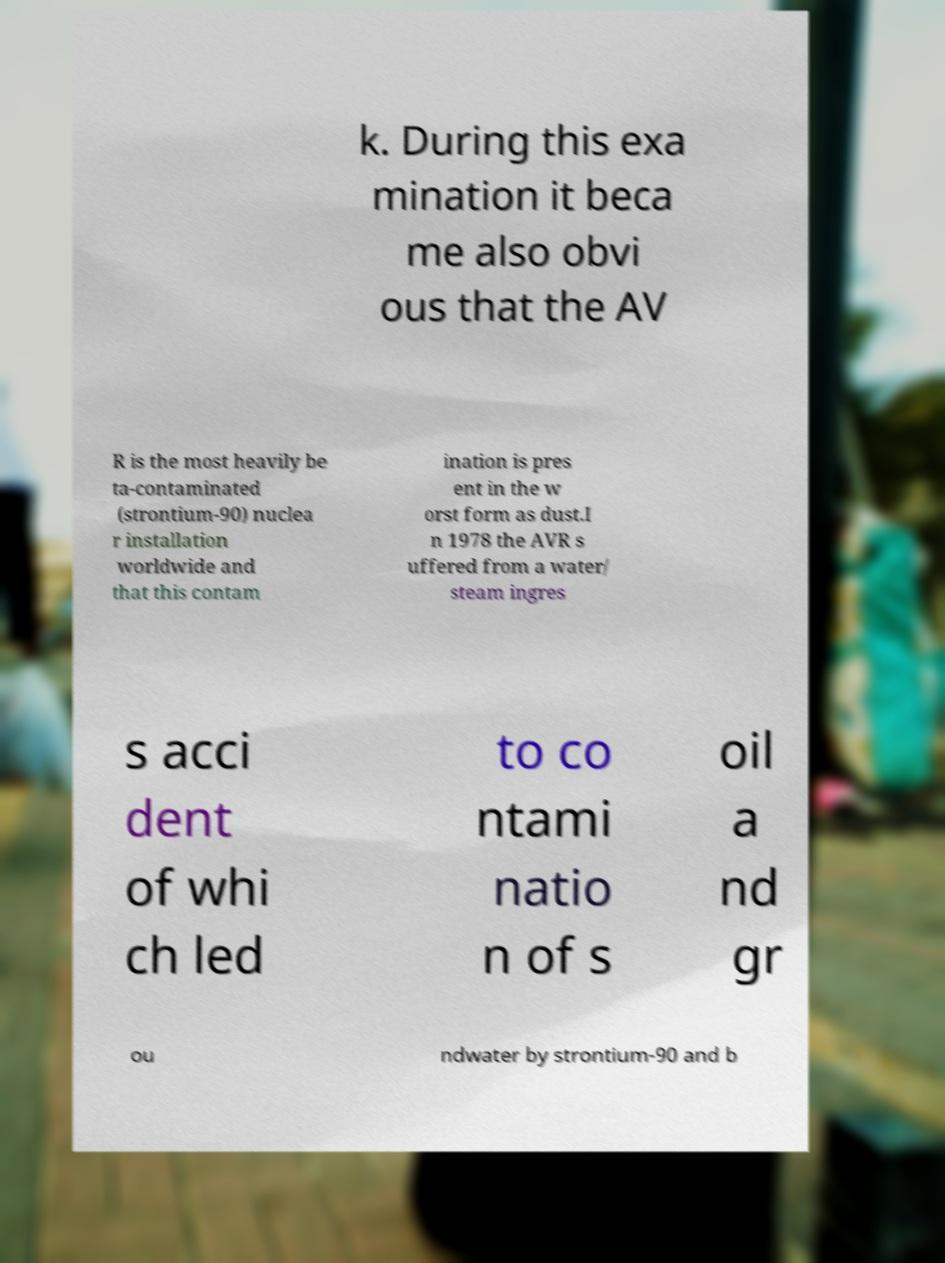Can you read and provide the text displayed in the image?This photo seems to have some interesting text. Can you extract and type it out for me? k. During this exa mination it beca me also obvi ous that the AV R is the most heavily be ta-contaminated (strontium-90) nuclea r installation worldwide and that this contam ination is pres ent in the w orst form as dust.I n 1978 the AVR s uffered from a water/ steam ingres s acci dent of whi ch led to co ntami natio n of s oil a nd gr ou ndwater by strontium-90 and b 